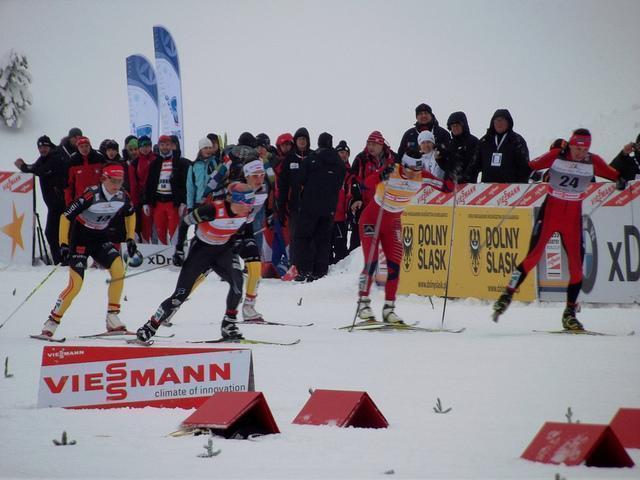What country does the sponsor closest to the camera have it's headquarters located?
From the following set of four choices, select the accurate answer to respond to the question.
Options: Israel, ukraine, germany, poland. Germany. 